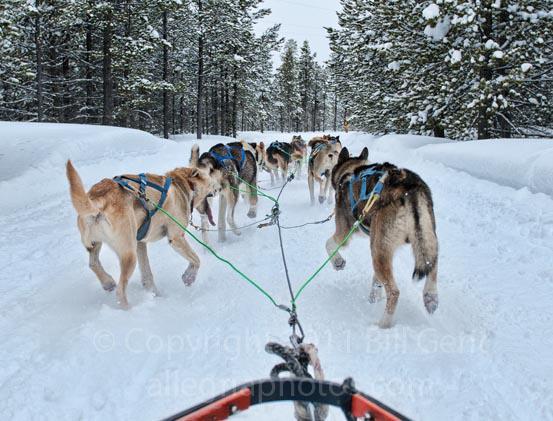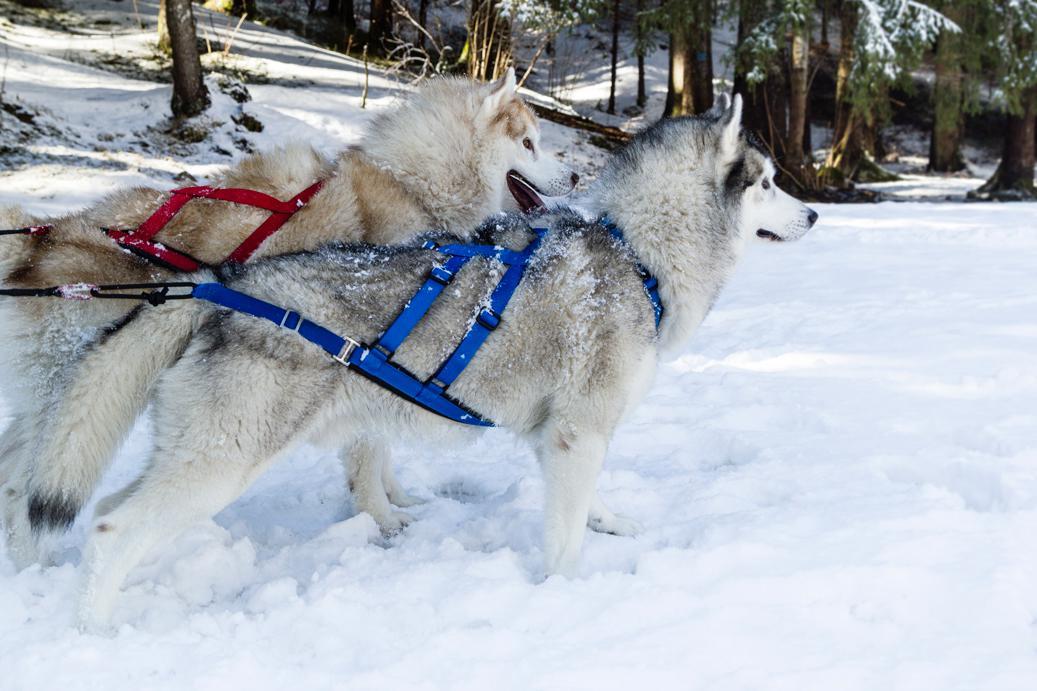The first image is the image on the left, the second image is the image on the right. Assess this claim about the two images: "In the left image, all dogs have blue harnesses.". Correct or not? Answer yes or no. Yes. The first image is the image on the left, the second image is the image on the right. Considering the images on both sides, is "The dog sled teams in the left and right images move forward over snow at some angle [instead of away from the camera] but are not heading toward each other." valid? Answer yes or no. No. 